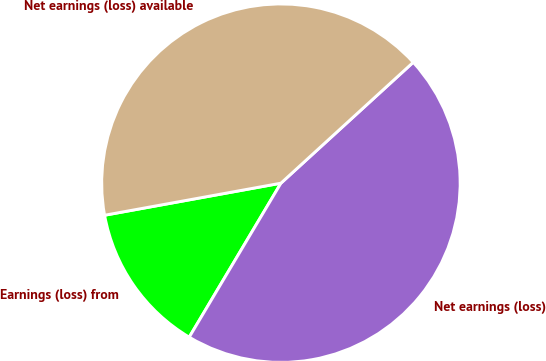<chart> <loc_0><loc_0><loc_500><loc_500><pie_chart><fcel>Earnings (loss) from<fcel>Net earnings (loss)<fcel>Net earnings (loss) available<nl><fcel>13.59%<fcel>45.33%<fcel>41.08%<nl></chart> 